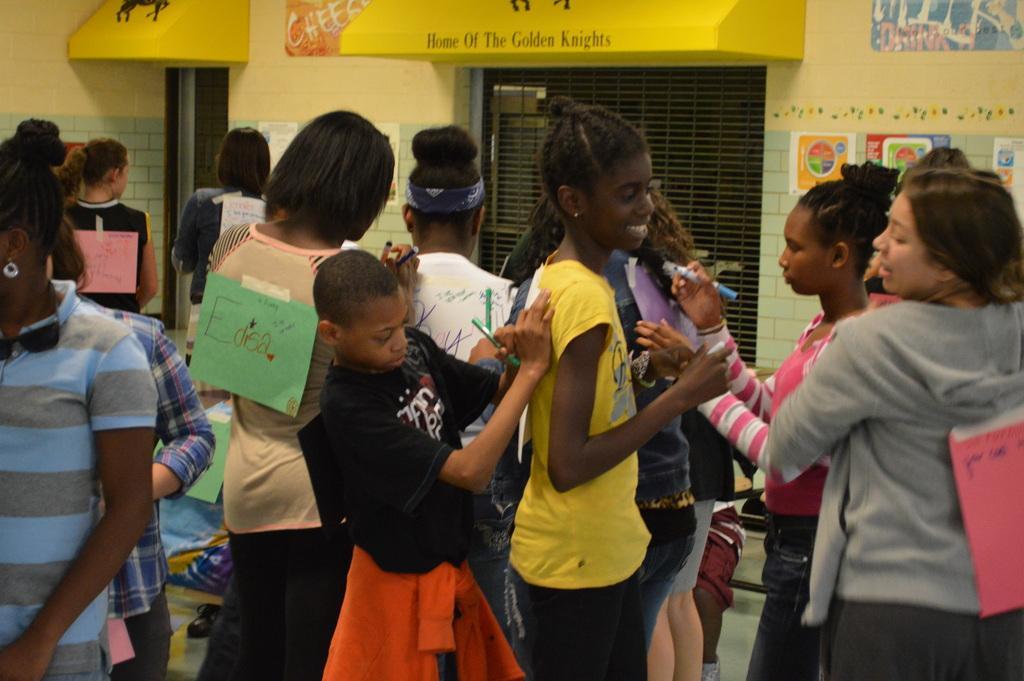Could you give a brief overview of what you see in this image? In this image we can see people standing on the floor and holding pens in their hands. In the background there are pipes attached to the walls, grills and advertisements. 